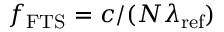<formula> <loc_0><loc_0><loc_500><loc_500>f _ { F T S } = c / ( N \lambda _ { r e f } )</formula> 